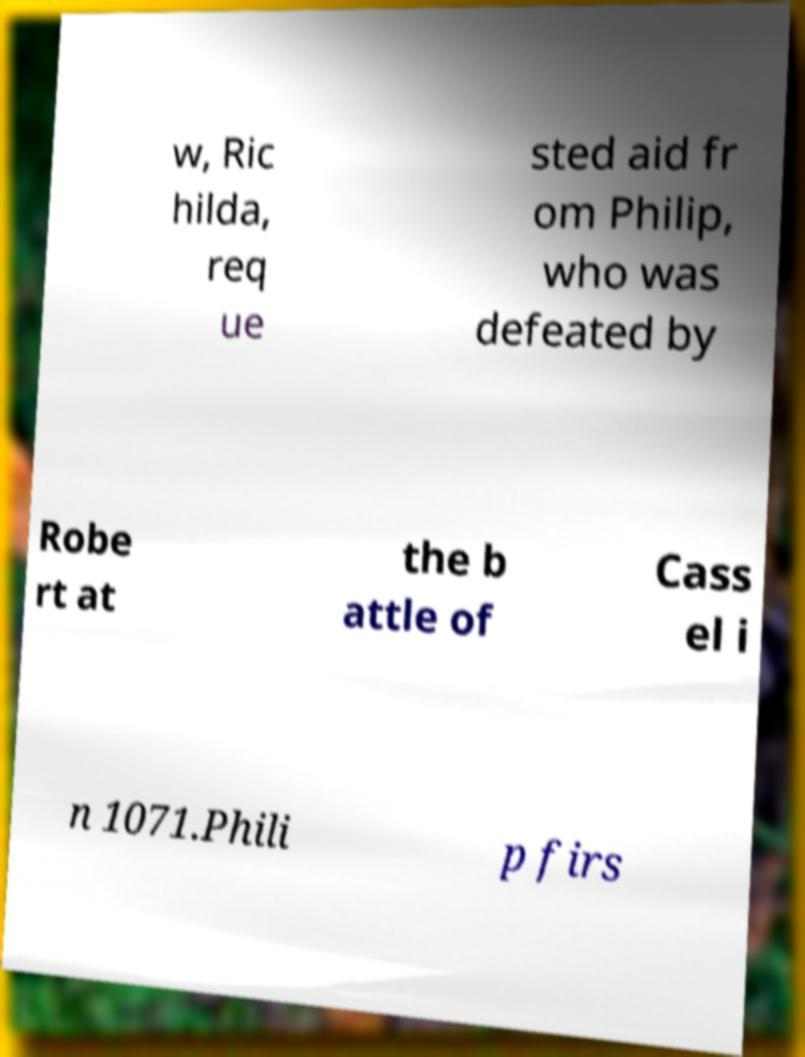Can you read and provide the text displayed in the image?This photo seems to have some interesting text. Can you extract and type it out for me? w, Ric hilda, req ue sted aid fr om Philip, who was defeated by Robe rt at the b attle of Cass el i n 1071.Phili p firs 